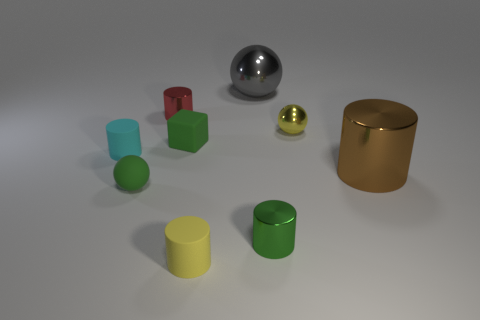Subtract all red cylinders. How many cylinders are left? 4 Subtract 1 blocks. How many blocks are left? 0 Add 1 brown spheres. How many objects exist? 10 Subtract all small green balls. Subtract all small objects. How many objects are left? 1 Add 9 tiny yellow rubber objects. How many tiny yellow rubber objects are left? 10 Add 2 tiny cyan matte things. How many tiny cyan matte things exist? 3 Subtract all yellow spheres. How many spheres are left? 2 Subtract 0 purple blocks. How many objects are left? 9 Subtract all cubes. How many objects are left? 8 Subtract all purple balls. Subtract all red blocks. How many balls are left? 3 